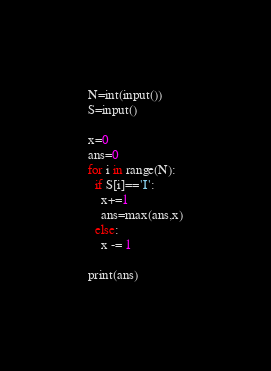Convert code to text. <code><loc_0><loc_0><loc_500><loc_500><_Python_>N=int(input())
S=input()

x=0
ans=0
for i in range(N):
  if S[i]=='I':
    x+=1
    ans=max(ans,x)
  else:
    x -= 1
    
print(ans)</code> 